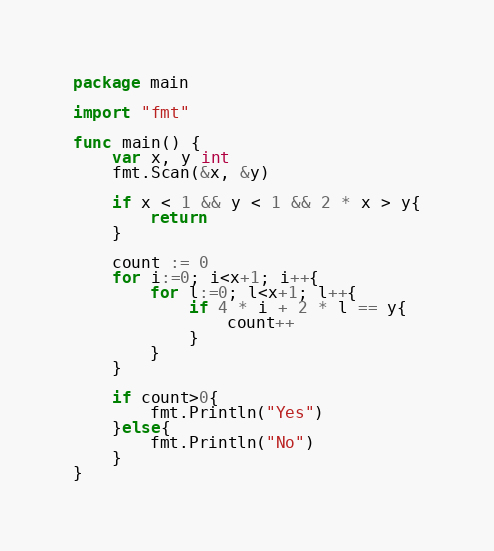Convert code to text. <code><loc_0><loc_0><loc_500><loc_500><_Go_>package main

import "fmt"

func main() {
	var x, y int
	fmt.Scan(&x, &y)

	if x < 1 && y < 1 && 2 * x > y{
		return
	}

	count := 0
	for i:=0; i<x+1; i++{
		for l:=0; l<x+1; l++{
			if 4 * i + 2 * l == y{
				count++
			}
		}
	}

	if count>0{
		fmt.Println("Yes")
	}else{
		fmt.Println("No")
	}
}</code> 